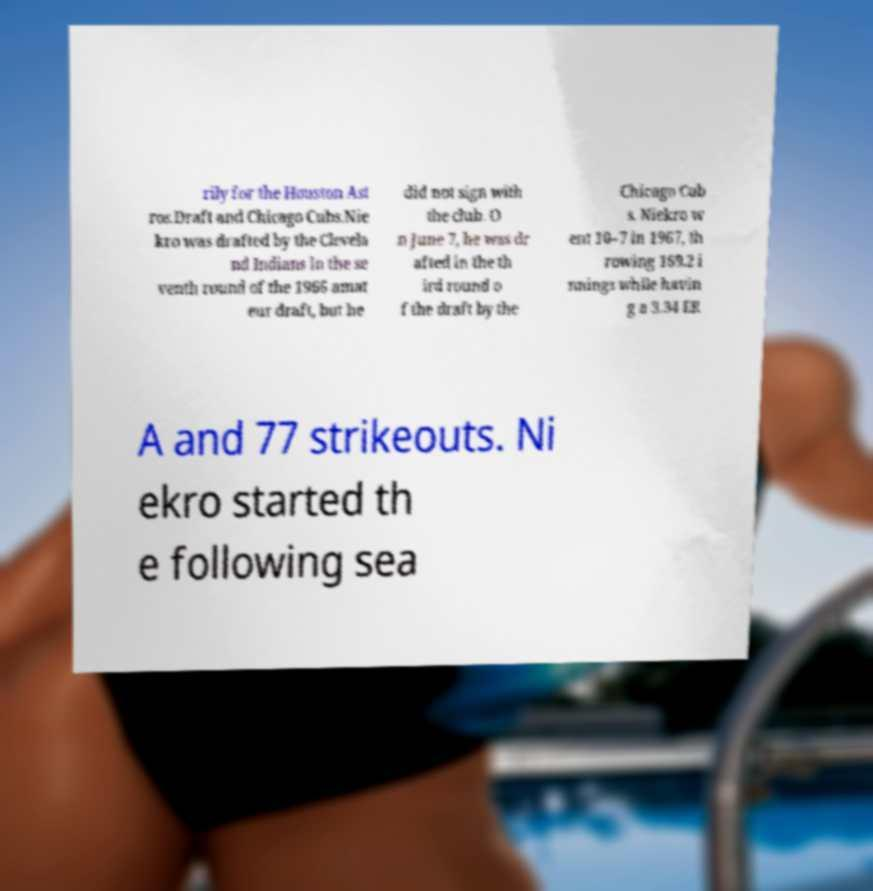For documentation purposes, I need the text within this image transcribed. Could you provide that? rily for the Houston Ast ros.Draft and Chicago Cubs.Nie kro was drafted by the Clevela nd Indians in the se venth round of the 1966 amat eur draft, but he did not sign with the club. O n June 7, he was dr afted in the th ird round o f the draft by the Chicago Cub s. Niekro w ent 10–7 in 1967, th rowing 169.2 i nnings while havin g a 3.34 ER A and 77 strikeouts. Ni ekro started th e following sea 